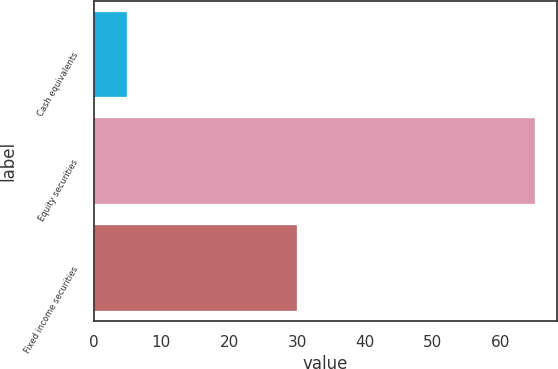Convert chart to OTSL. <chart><loc_0><loc_0><loc_500><loc_500><bar_chart><fcel>Cash equivalents<fcel>Equity securities<fcel>Fixed income securities<nl><fcel>5<fcel>65<fcel>30<nl></chart> 